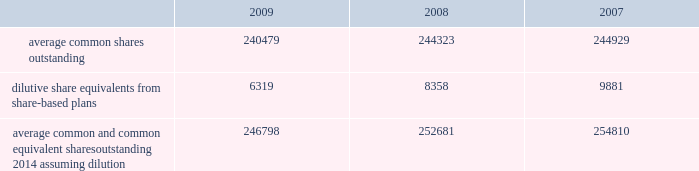The company has a restricted stock plan for non-employee directors which reserves for issuance of 300000 shares of the company 2019s common stock .
No restricted shares were issued in 2009 .
The company has a directors 2019 deferral plan , which provides a means to defer director compensation , from time to time , on a deferred stock or cash basis .
As of september 30 , 2009 , 86643 shares were held in trust , of which 4356 shares represented directors 2019 compensation in 2009 , in accordance with the provisions of the plan .
Under this plan , which is unfunded , directors have an unsecured contractual commitment from the company .
The company also has a deferred compensation plan that allows certain highly-compensated employees , including executive officers , to defer salary , annual incentive awards and certain equity-based compensation .
As of september 30 , 2009 , 557235 shares were issuable under this plan .
Note 16 2014 earnings per share the weighted average common shares used in the computations of basic and diluted earnings per share ( shares in thousands ) for the years ended september 30 were as follows: .
Average common and common equivalent shares outstanding 2014 assuming dilution .
246798 252681 254810 note 17 2014 segment data the company 2019s organizational structure is based upon its three principal business segments : bd medical ( 201cmedical 201d ) , bd diagnostics ( 201cdiagnostics 201d ) and bd biosciences ( 201cbiosciences 201d ) .
The principal product lines in the medical segment include needles , syringes and intravenous catheters for medication delivery ; safety-engineered and auto-disable devices ; prefilled iv flush syringes ; syringes and pen needles for the self-injection of insulin and other drugs used in the treatment of diabetes ; prefillable drug delivery devices provided to pharmaceutical companies and sold to end-users as drug/device combinations ; surgical blades/scalpels and regional anesthesia needles and trays ; critical care monitoring devices ; ophthalmic surgical instruments ; and sharps disposal containers .
The principal products and services in the diagnostics segment include integrated systems for specimen collection ; an extensive line of safety-engineered specimen blood collection products and systems ; plated media ; automated blood culturing systems ; molecular testing systems for sexually transmitted diseases and healthcare-associated infections ; microorganism identification and drug susceptibility systems ; liquid-based cytology systems for cervical cancer screening ; and rapid diagnostic assays .
The principal product lines in the biosciences segment include fluorescence activated cell sorters and analyzers ; cell imaging systems ; monoclonal antibodies and kits for performing cell analysis ; reagent systems for life sciences research ; tools to aid in drug discovery and growth of tissue and cells ; cell culture media supplements for biopharmaceutical manufacturing ; and diagnostic assays .
The company evaluates performance of its business segments based upon operating income .
Segment operating income represents revenues reduced by product costs and operating expenses .
The company hedges against certain forecasted sales of u.s.-produced products sold outside the united states .
Gains and losses associated with these foreign currency translation hedges are reported in segment revenues based upon their proportionate share of these international sales of u.s.-produced products .
Becton , dickinson and company notes to consolidated financial statements 2014 ( continued ) .
In 2009 what was the percent of the total average common and common equivalent shares outstanding that was dilutive share equivalents from share-based plans? 
Computations: (6319 / 246798)
Answer: 0.0256. 